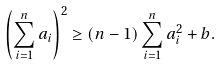Convert formula to latex. <formula><loc_0><loc_0><loc_500><loc_500>\left ( \sum _ { i = 1 } ^ { n } a _ { i } \right ) ^ { 2 } \geq ( n - 1 ) \sum _ { i = 1 } ^ { n } a _ { i } ^ { 2 } + b .</formula> 